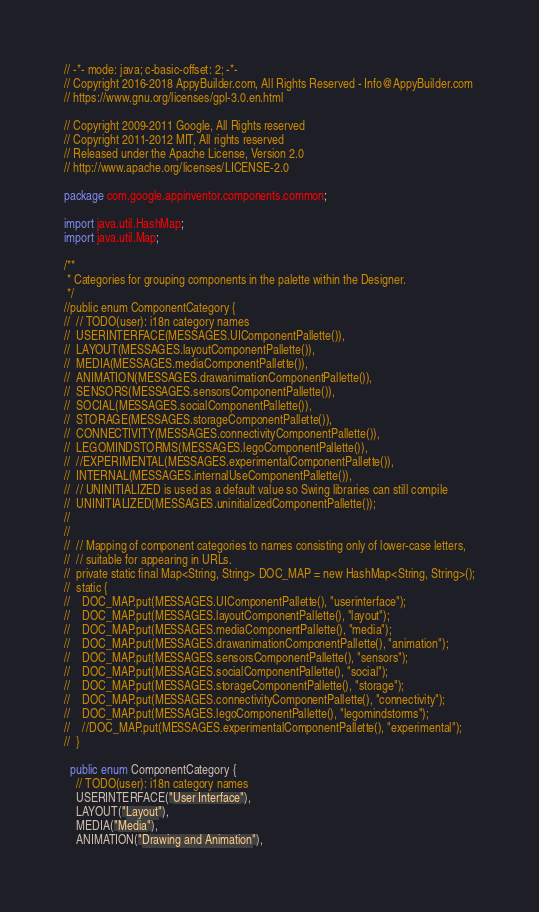<code> <loc_0><loc_0><loc_500><loc_500><_Java_>// -*- mode: java; c-basic-offset: 2; -*-
// Copyright 2016-2018 AppyBuilder.com, All Rights Reserved - Info@AppyBuilder.com
// https://www.gnu.org/licenses/gpl-3.0.en.html

// Copyright 2009-2011 Google, All Rights reserved
// Copyright 2011-2012 MIT, All rights reserved
// Released under the Apache License, Version 2.0
// http://www.apache.org/licenses/LICENSE-2.0

package com.google.appinventor.components.common;

import java.util.HashMap;
import java.util.Map;

/**
 * Categories for grouping components in the palette within the Designer.
 */
//public enum ComponentCategory {
//  // TODO(user): i18n category names
//  USERINTERFACE(MESSAGES.UIComponentPallette()),
//  LAYOUT(MESSAGES.layoutComponentPallette()),
//  MEDIA(MESSAGES.mediaComponentPallette()),
//  ANIMATION(MESSAGES.drawanimationComponentPallette()),
//  SENSORS(MESSAGES.sensorsComponentPallette()),
//  SOCIAL(MESSAGES.socialComponentPallette()),
//  STORAGE(MESSAGES.storageComponentPallette()),
//  CONNECTIVITY(MESSAGES.connectivityComponentPallette()),
//  LEGOMINDSTORMS(MESSAGES.legoComponentPallette()),
//  //EXPERIMENTAL(MESSAGES.experimentalComponentPallette()),
//  INTERNAL(MESSAGES.internalUseComponentPallette()),
//  // UNINITIALIZED is used as a default value so Swing libraries can still compile
//  UNINITIALIZED(MESSAGES.uninitializedComponentPallette());
//
//
//  // Mapping of component categories to names consisting only of lower-case letters,
//  // suitable for appearing in URLs.
//  private static final Map<String, String> DOC_MAP = new HashMap<String, String>();
//  static {
//    DOC_MAP.put(MESSAGES.UIComponentPallette(), "userinterface");
//    DOC_MAP.put(MESSAGES.layoutComponentPallette(), "layout");
//    DOC_MAP.put(MESSAGES.mediaComponentPallette(), "media");
//    DOC_MAP.put(MESSAGES.drawanimationComponentPallette(), "animation");
//    DOC_MAP.put(MESSAGES.sensorsComponentPallette(), "sensors");
//    DOC_MAP.put(MESSAGES.socialComponentPallette(), "social");
//    DOC_MAP.put(MESSAGES.storageComponentPallette(), "storage");
//    DOC_MAP.put(MESSAGES.connectivityComponentPallette(), "connectivity");
//    DOC_MAP.put(MESSAGES.legoComponentPallette(), "legomindstorms");
//    //DOC_MAP.put(MESSAGES.experimentalComponentPallette(), "experimental");
//  }

  public enum ComponentCategory {
    // TODO(user): i18n category names
    USERINTERFACE("User Interface"),
    LAYOUT("Layout"),
    MEDIA("Media"),
    ANIMATION("Drawing and Animation"),</code> 